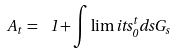Convert formula to latex. <formula><loc_0><loc_0><loc_500><loc_500>A _ { t } \, = \, \ 1 + \int \lim i t s _ { 0 } ^ { t } d s G _ { s }</formula> 